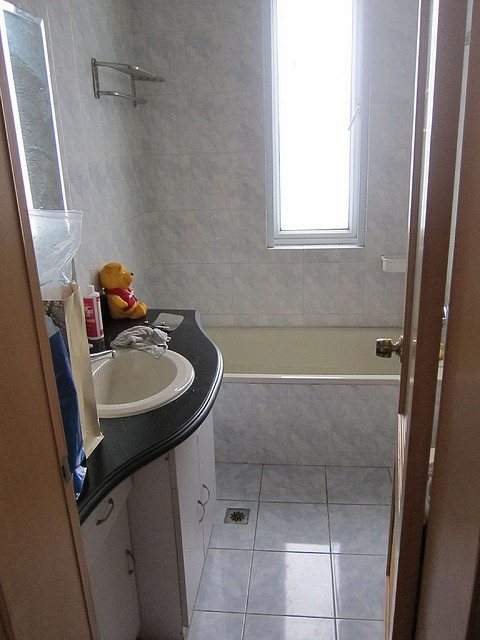Describe the objects in this image and their specific colors. I can see sink in white, gray, and darkgray tones, teddy bear in white, olive, maroon, and darkgray tones, and bottle in ivory, maroon, darkgray, gray, and black tones in this image. 